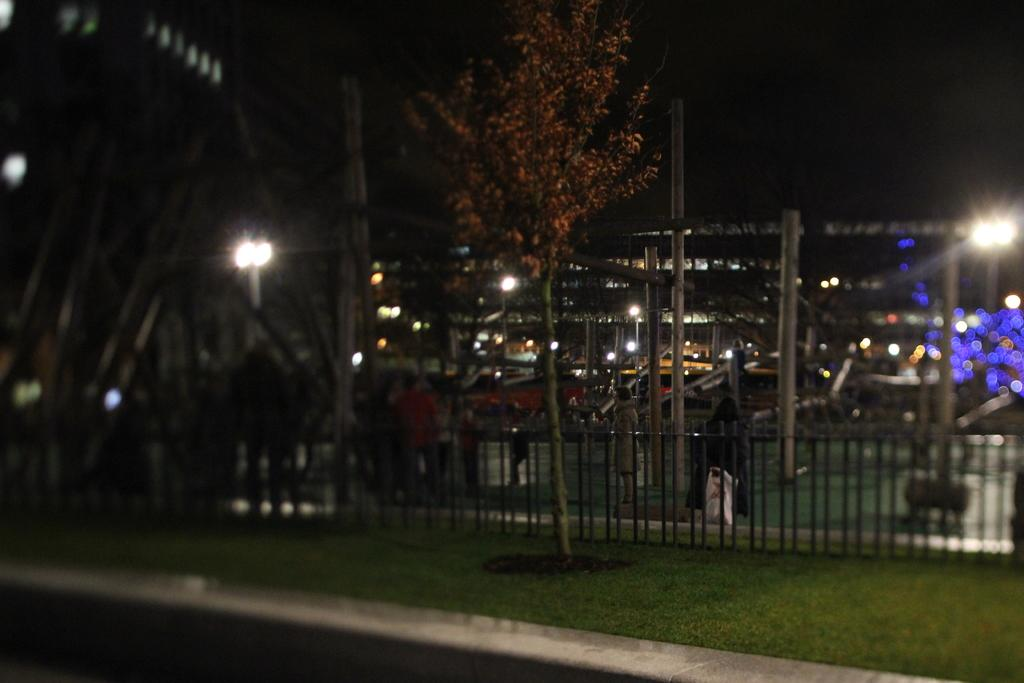What type of natural elements can be seen in the image? There are trees in the image. What man-made structures are present in the image? There are poles, lights, grilles, buildings, and people in the image. What part of the natural environment is visible in the image? The ground is visible at the bottom of the image. What part of the sky is visible in the image? The sky is visible at the top of the image. Can you see a window in the image? There is no window present in the image. Is there a girl in the image? There is no girl mentioned in the provided facts, so we cannot definitively say if a girl is present in the image. 